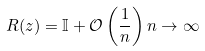Convert formula to latex. <formula><loc_0><loc_0><loc_500><loc_500>R ( z ) = \mathbb { I } + \mathcal { O } \left ( \frac { 1 } { n } \right ) n \to \infty</formula> 